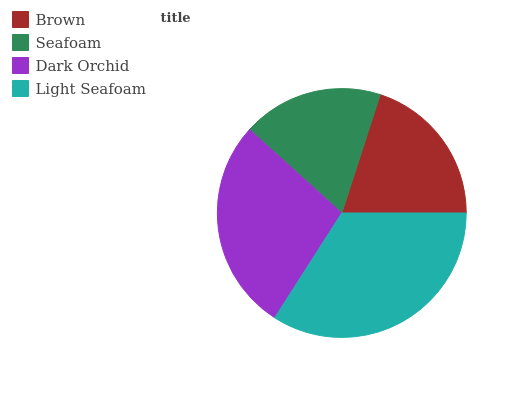Is Seafoam the minimum?
Answer yes or no. Yes. Is Light Seafoam the maximum?
Answer yes or no. Yes. Is Dark Orchid the minimum?
Answer yes or no. No. Is Dark Orchid the maximum?
Answer yes or no. No. Is Dark Orchid greater than Seafoam?
Answer yes or no. Yes. Is Seafoam less than Dark Orchid?
Answer yes or no. Yes. Is Seafoam greater than Dark Orchid?
Answer yes or no. No. Is Dark Orchid less than Seafoam?
Answer yes or no. No. Is Dark Orchid the high median?
Answer yes or no. Yes. Is Brown the low median?
Answer yes or no. Yes. Is Light Seafoam the high median?
Answer yes or no. No. Is Dark Orchid the low median?
Answer yes or no. No. 